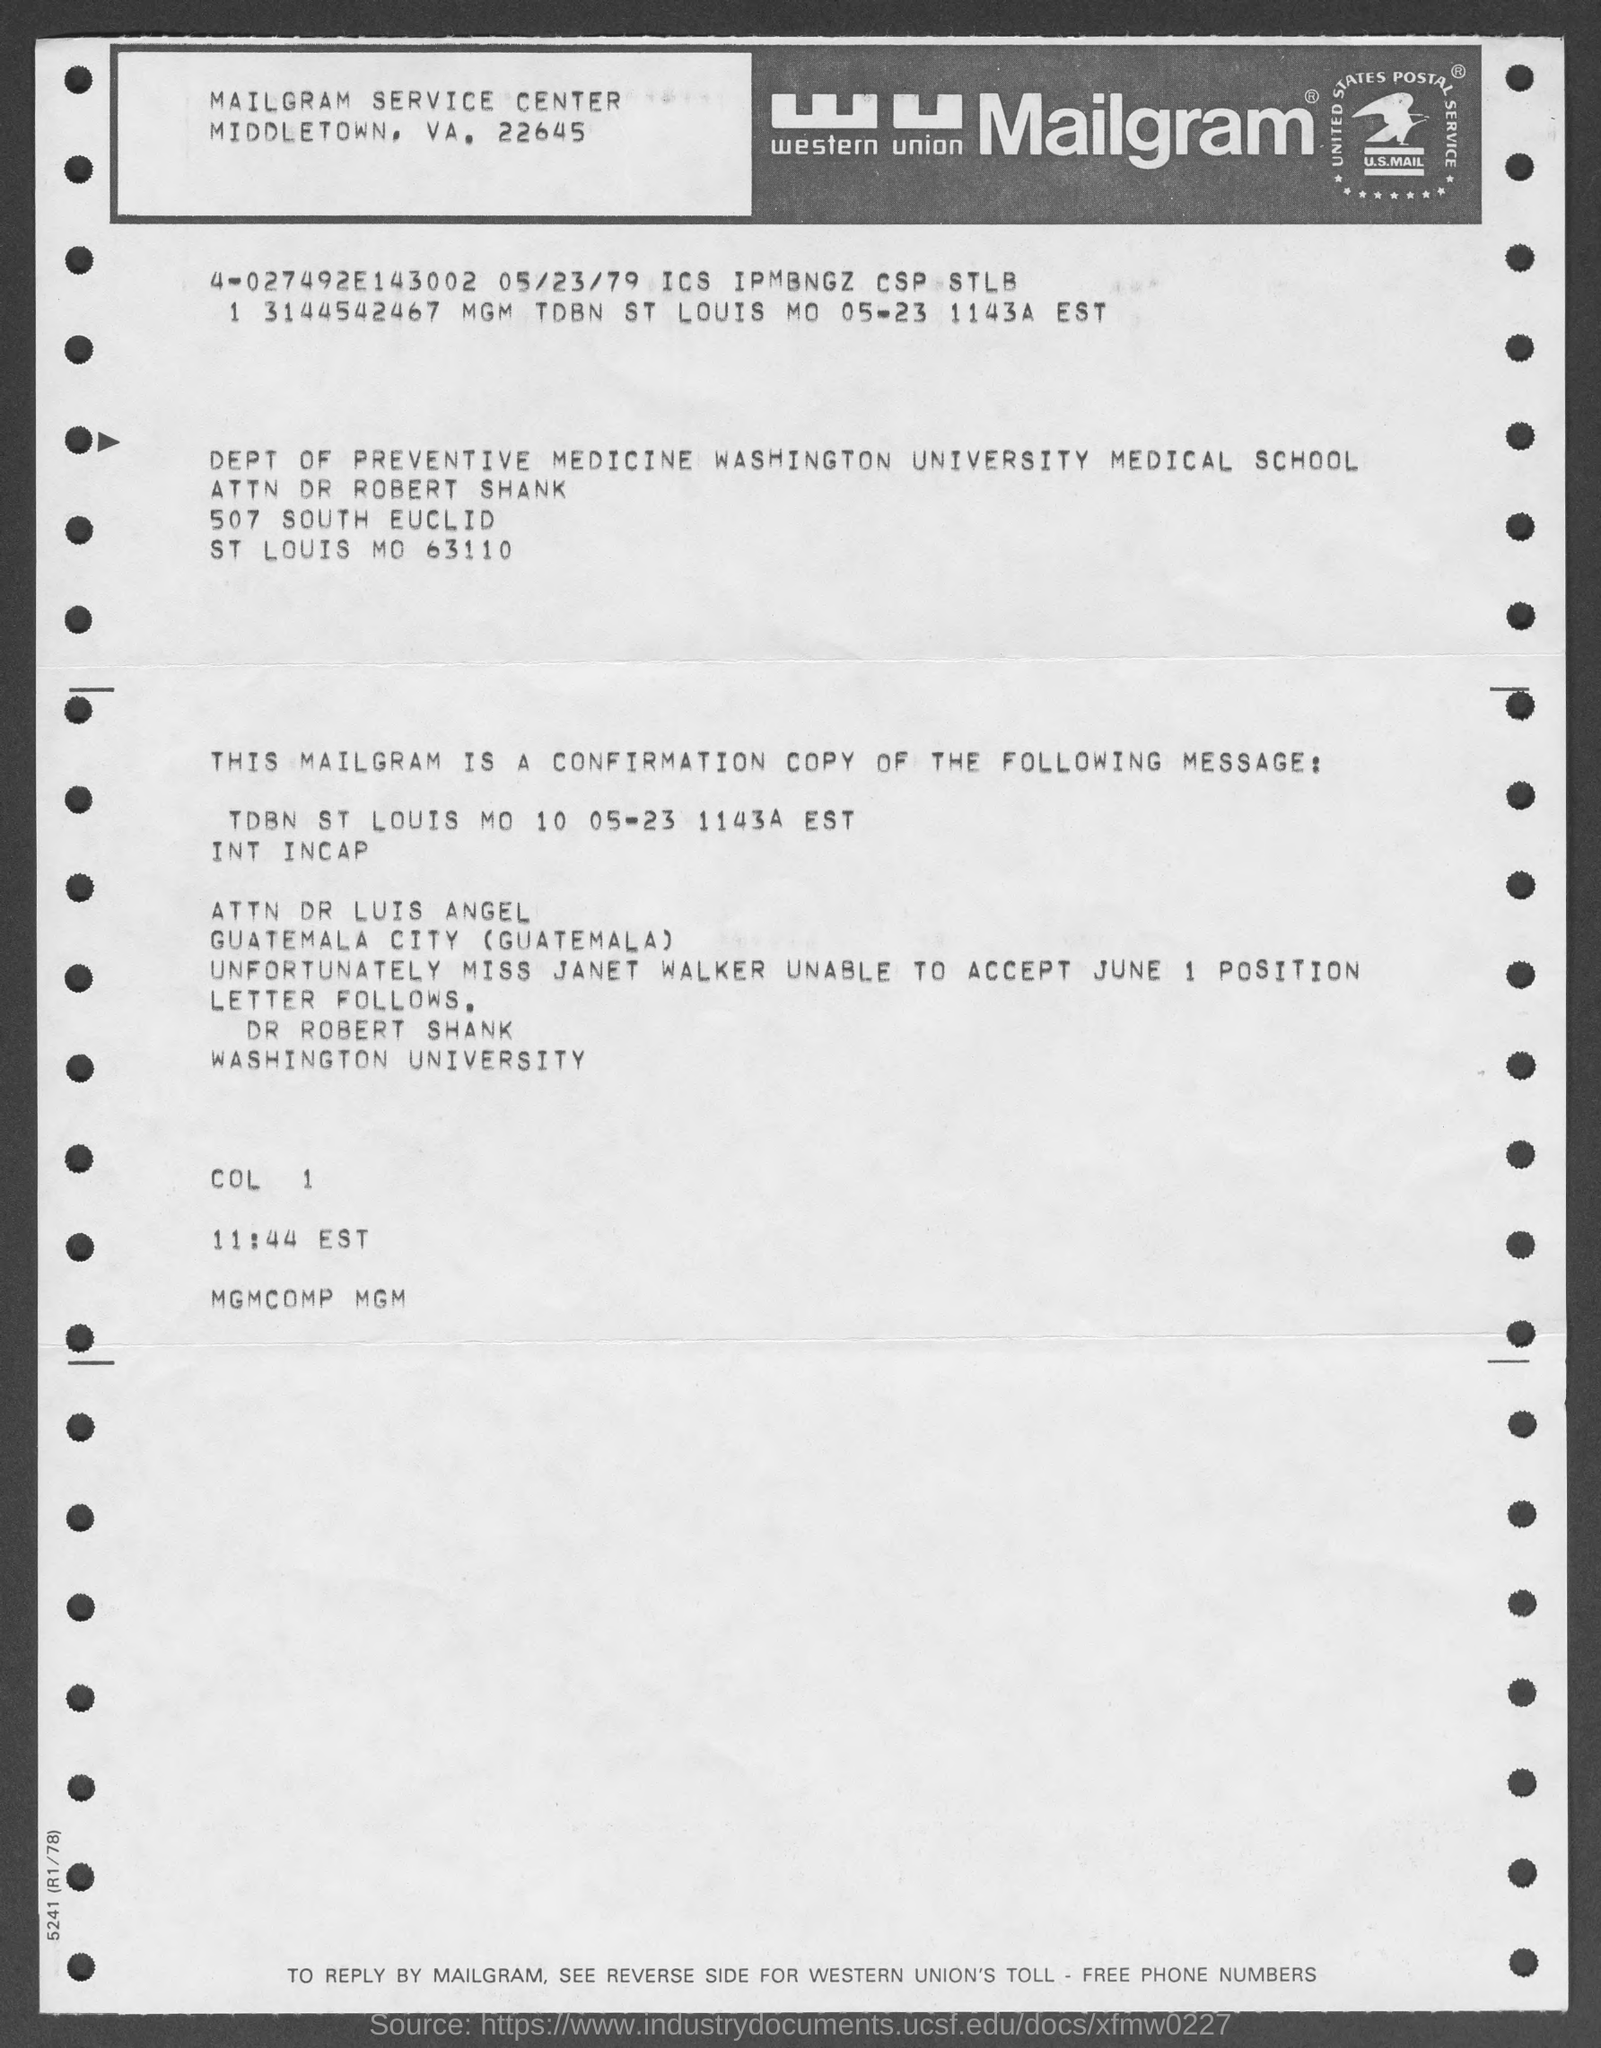What type of document is this?
Offer a very short reply. MAILGRAM. Where the 'Mailgram service center' is located ?
Keep it short and to the point. MIDDLETOWN, VA, 22645. What is the full form of ' wu' ?
Give a very brief answer. Western union. What is written inside the logo ?
Keep it short and to the point. U.S.MAIL. 